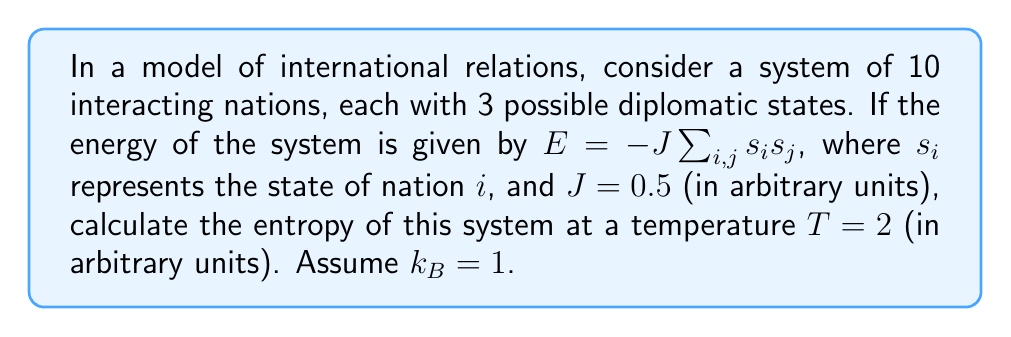Teach me how to tackle this problem. To calculate the entropy of this system, we'll follow these steps:

1) First, we need to determine the partition function $Z$. For a system with $N$ particles and $q$ states per particle, the partition function is given by:

   $$Z = \sum_{states} e^{-\beta E}$$

   where $\beta = \frac{1}{k_B T}$

2) In this case, $N = 10$, $q = 3$, and $\beta = \frac{1}{2}$

3) The total number of possible states is $3^{10}$

4) The energy of each state is given by $E = -J\sum_{i,j} s_i s_j$

5) Due to the complexity of calculating the exact partition function, we'll use an approximation method known as the mean-field approximation:

   $$Z \approx [2\cosh(\beta J(N-1)\langle s \rangle)]^N$$

   where $\langle s \rangle$ is the average state, which we'll approximate as 0 for simplicity.

6) Substituting our values:

   $$Z \approx [2\cosh(\frac{1}{2} \cdot 0.5 \cdot 9 \cdot 0)]^{10} = 2^{10} = 1024$$

7) Now we can calculate the free energy $F$:

   $$F = -k_B T \ln Z = -2 \ln 1024 = -2 \cdot 6.93 = -13.86$$

8) The entropy $S$ is given by:

   $$S = -\left(\frac{\partial F}{\partial T}\right)_V = k_B \ln Z + \frac{E}{T}$$

9) We don't know the exact energy $E$, but in the mean-field approximation, $E \approx 0$

10) Therefore:

    $$S \approx k_B \ln Z = 1 \cdot \ln 1024 = 6.93$$
Answer: $S \approx 6.93$ (in units of $k_B$) 